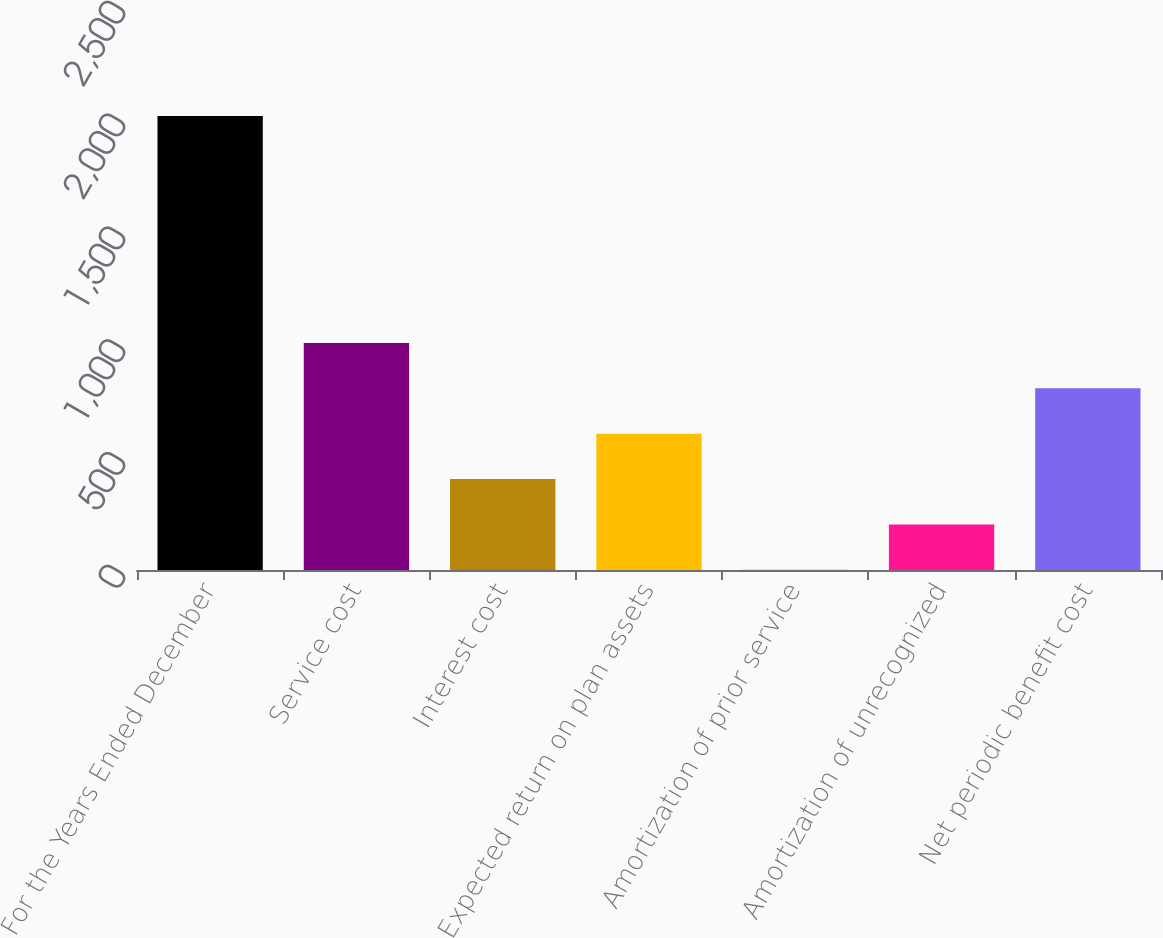Convert chart. <chart><loc_0><loc_0><loc_500><loc_500><bar_chart><fcel>For the Years Ended December<fcel>Service cost<fcel>Interest cost<fcel>Expected return on plan assets<fcel>Amortization of prior service<fcel>Amortization of unrecognized<fcel>Net periodic benefit cost<nl><fcel>2012<fcel>1006.45<fcel>403.12<fcel>604.23<fcel>0.9<fcel>202.01<fcel>805.34<nl></chart> 